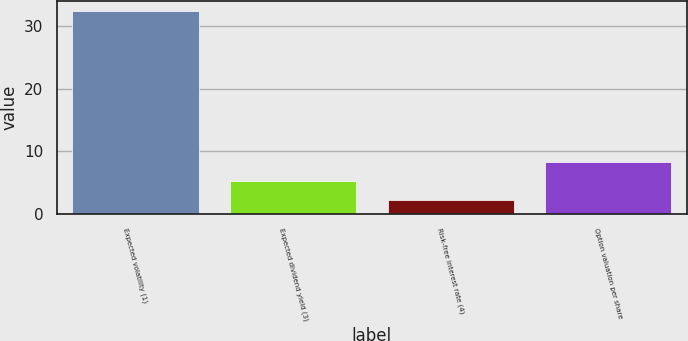Convert chart to OTSL. <chart><loc_0><loc_0><loc_500><loc_500><bar_chart><fcel>Expected volatility (1)<fcel>Expected dividend yield (3)<fcel>Risk-free interest rate (4)<fcel>Option valuation per share<nl><fcel>32.4<fcel>5.3<fcel>2.29<fcel>8.31<nl></chart> 